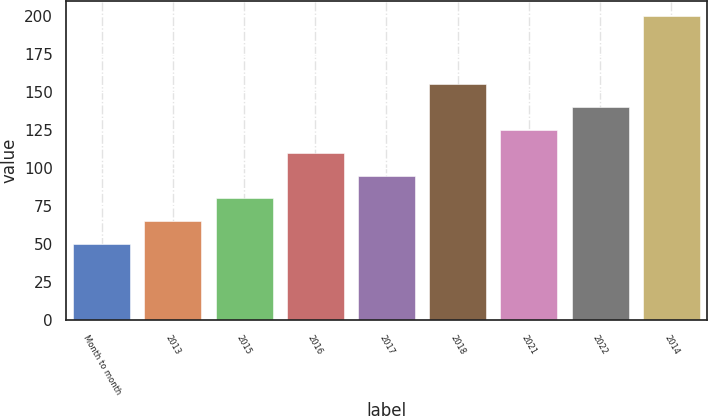<chart> <loc_0><loc_0><loc_500><loc_500><bar_chart><fcel>Month to month<fcel>2013<fcel>2015<fcel>2016<fcel>2017<fcel>2018<fcel>2021<fcel>2022<fcel>2014<nl><fcel>50.16<fcel>65.14<fcel>80.12<fcel>110.08<fcel>95.1<fcel>155.02<fcel>125.06<fcel>140.04<fcel>199.94<nl></chart> 